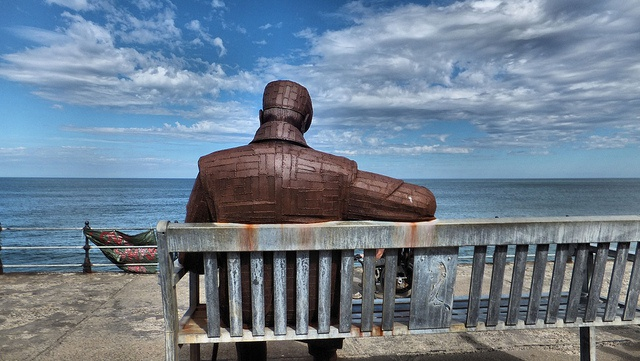Describe the objects in this image and their specific colors. I can see bench in gray, darkgray, and black tones and people in gray, black, maroon, and brown tones in this image. 